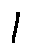<formula> <loc_0><loc_0><loc_500><loc_500>1</formula> 